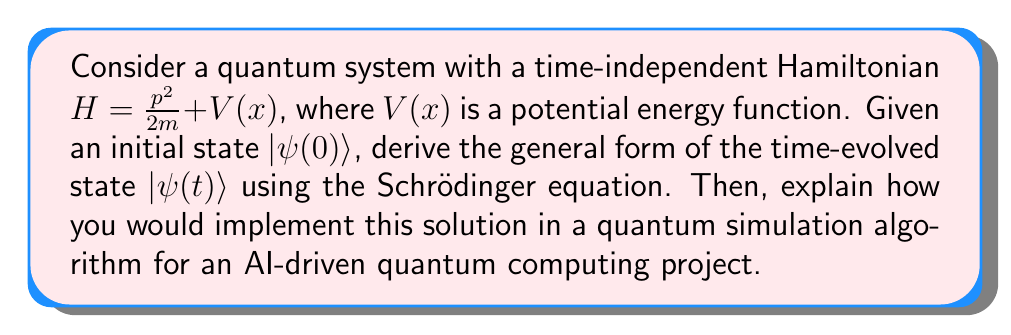Give your solution to this math problem. 1. Start with the time-dependent Schrödinger equation:
   $$i\hbar\frac{\partial}{\partial t}|\psi(t)\rangle = H|\psi(t)\rangle$$

2. For a time-independent Hamiltonian, we can separate variables:
   $$|\psi(t)\rangle = e^{-iHt/\hbar}|\psi(0)\rangle$$

3. Expand $|\psi(0)\rangle$ in terms of energy eigenstates $|E_n\rangle$:
   $$|\psi(0)\rangle = \sum_n c_n|E_n\rangle$$
   where $c_n = \langle E_n|\psi(0)\rangle$

4. Apply the time evolution operator:
   $$|\psi(t)\rangle = e^{-iHt/\hbar}\sum_n c_n|E_n\rangle = \sum_n c_ne^{-iE_nt/\hbar}|E_n\rangle$$

5. To implement this in a quantum simulation algorithm:
   a) Discretize the Hamiltonian and compute its eigenstates $|E_n\rangle$ and eigenvalues $E_n$.
   b) Prepare the initial state $|\psi(0)\rangle$ on the quantum computer.
   c) Apply quantum gates to implement the time evolution operator $e^{-iHt/\hbar}$.
   d) Measure the final state to obtain information about $|\psi(t)\rangle$.

6. For an AI-driven project, machine learning techniques can be used to:
   a) Optimize the quantum circuit design for the time evolution operator.
   b) Predict the behavior of $|\psi(t)\rangle$ for different initial states and Hamiltonians.
   c) Analyze measurement results and reconstruct the evolved quantum state.
Answer: $|\psi(t)\rangle = \sum_n c_ne^{-iE_nt/\hbar}|E_n\rangle$, where $c_n = \langle E_n|\psi(0)\rangle$ 